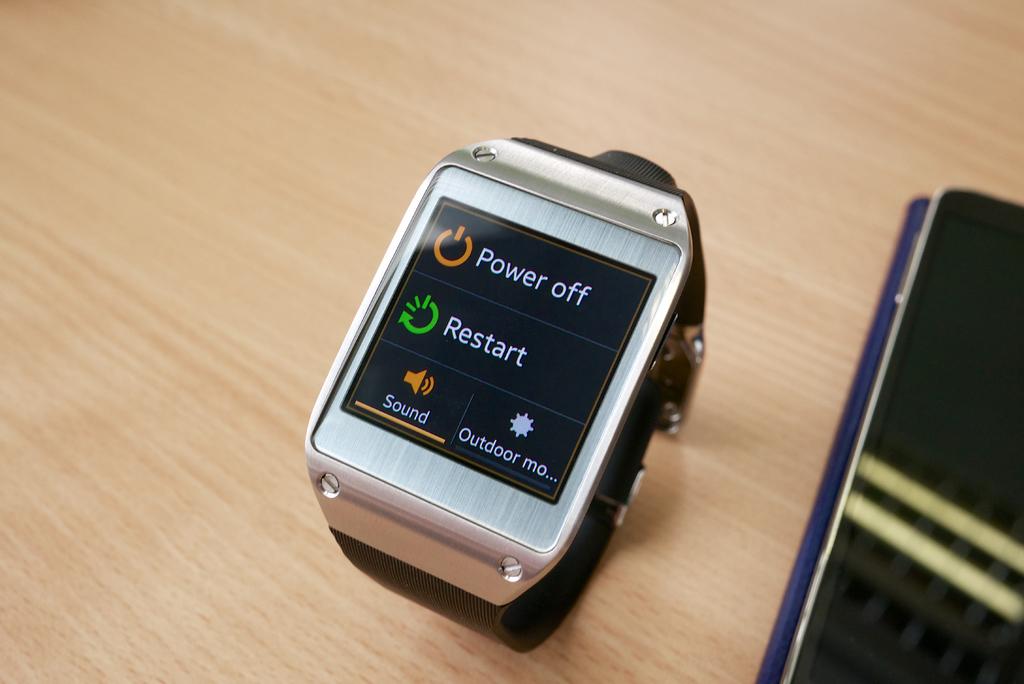What does the top line say?
Ensure brevity in your answer.  Power off. What is next to green button?
Offer a very short reply. Restart. 